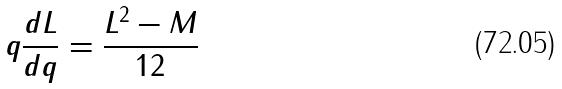<formula> <loc_0><loc_0><loc_500><loc_500>q \frac { d L } { d q } = \frac { L ^ { 2 } - M } { 1 2 }</formula> 